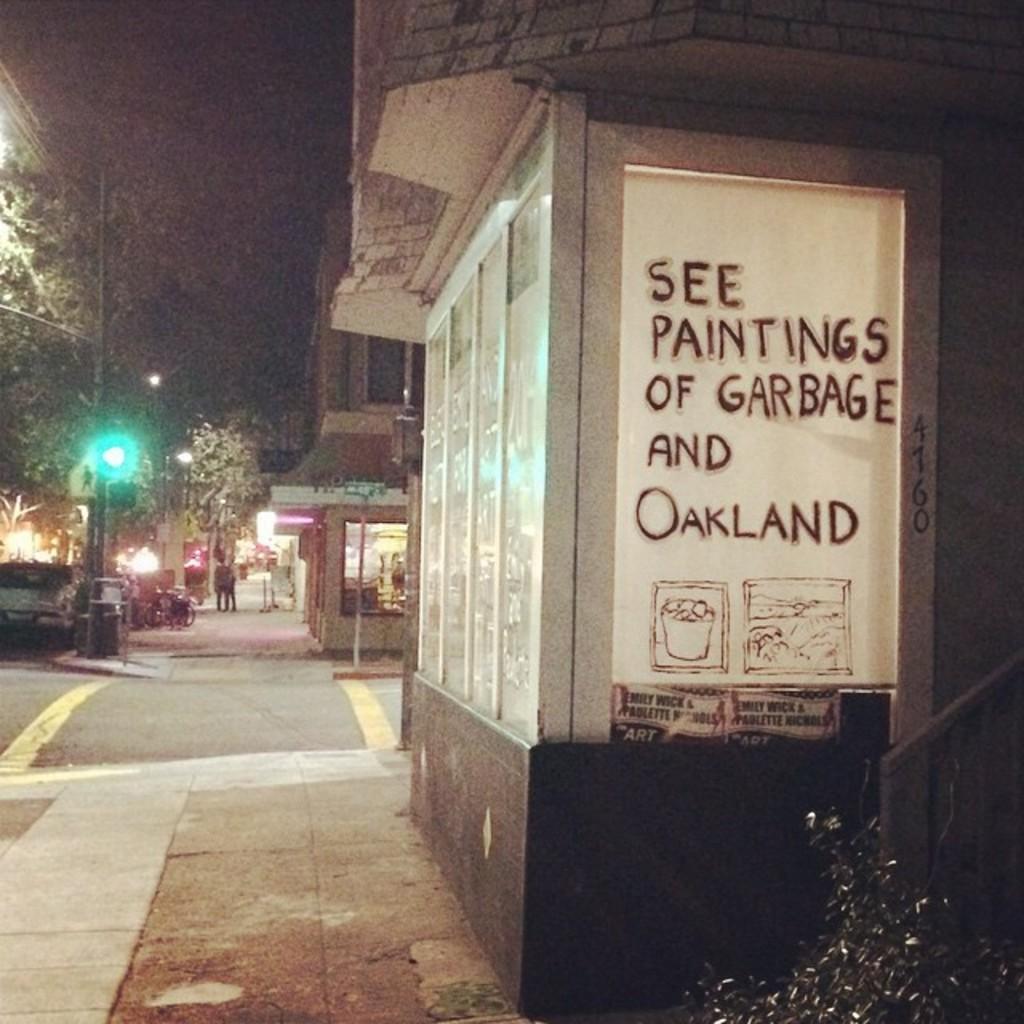In one or two sentences, can you explain what this image depicts? In the picture we can see a road and beside it, we can see a pole with a light and a car and near to the road we can see a path and a building with glass window and some white color board on it written as see a painting of garbage of Oakland and in the background we can see some buildings and tree. 